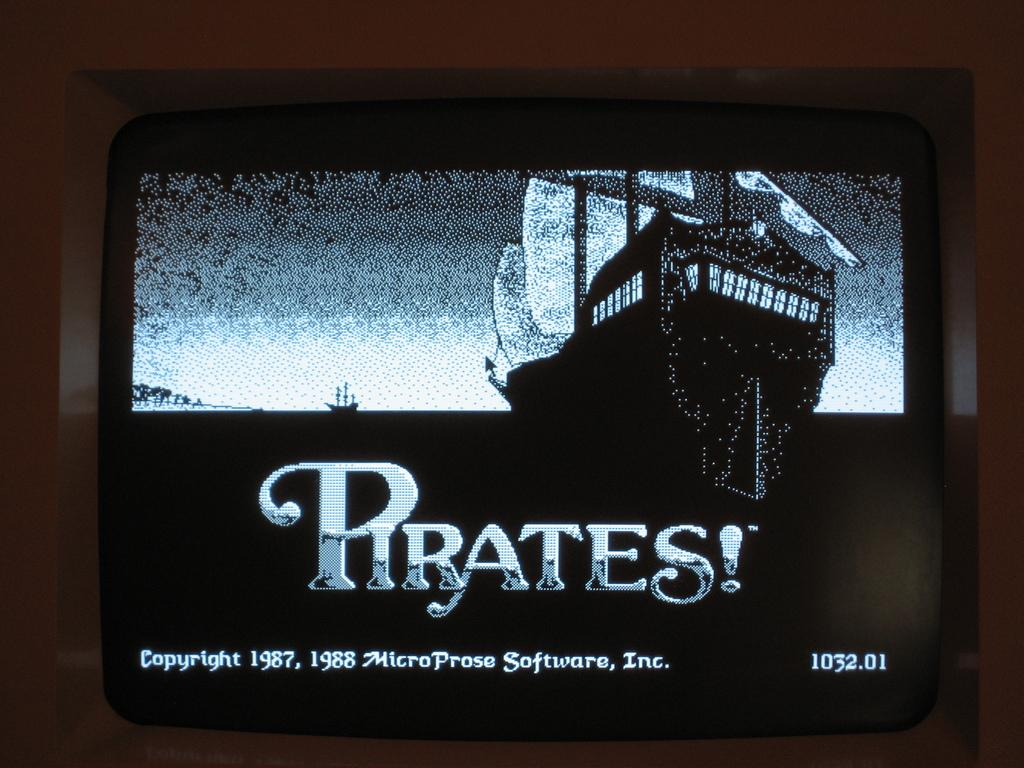<image>
Summarize the visual content of the image. A game called Pirates! was developed by MicroProse Software, Inc. 